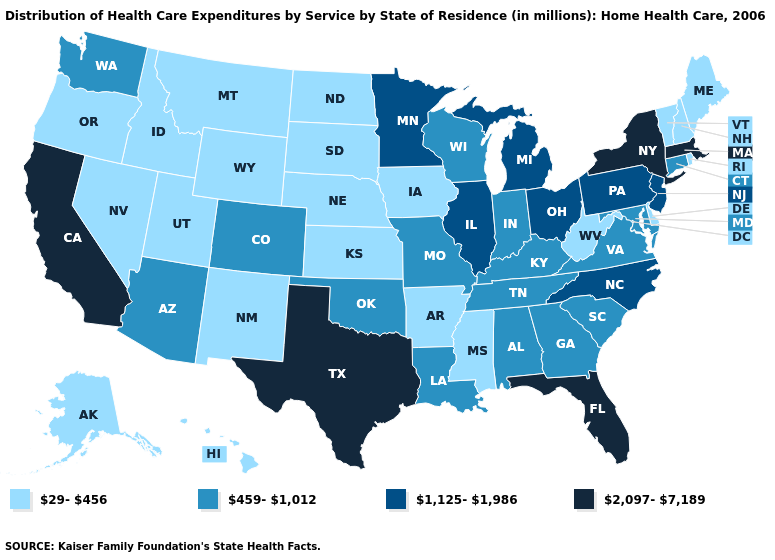Does North Dakota have the highest value in the MidWest?
Answer briefly. No. What is the value of Texas?
Short answer required. 2,097-7,189. Which states have the lowest value in the South?
Concise answer only. Arkansas, Delaware, Mississippi, West Virginia. Name the states that have a value in the range 459-1,012?
Write a very short answer. Alabama, Arizona, Colorado, Connecticut, Georgia, Indiana, Kentucky, Louisiana, Maryland, Missouri, Oklahoma, South Carolina, Tennessee, Virginia, Washington, Wisconsin. Among the states that border Maine , which have the highest value?
Short answer required. New Hampshire. What is the lowest value in states that border Nebraska?
Be succinct. 29-456. Does Kansas have a higher value than Utah?
Write a very short answer. No. What is the highest value in the USA?
Keep it brief. 2,097-7,189. Does North Carolina have the lowest value in the South?
Quick response, please. No. Among the states that border Indiana , which have the lowest value?
Give a very brief answer. Kentucky. Name the states that have a value in the range 2,097-7,189?
Write a very short answer. California, Florida, Massachusetts, New York, Texas. Which states have the highest value in the USA?
Short answer required. California, Florida, Massachusetts, New York, Texas. What is the value of Pennsylvania?
Quick response, please. 1,125-1,986. Name the states that have a value in the range 29-456?
Short answer required. Alaska, Arkansas, Delaware, Hawaii, Idaho, Iowa, Kansas, Maine, Mississippi, Montana, Nebraska, Nevada, New Hampshire, New Mexico, North Dakota, Oregon, Rhode Island, South Dakota, Utah, Vermont, West Virginia, Wyoming. Which states have the highest value in the USA?
Write a very short answer. California, Florida, Massachusetts, New York, Texas. 